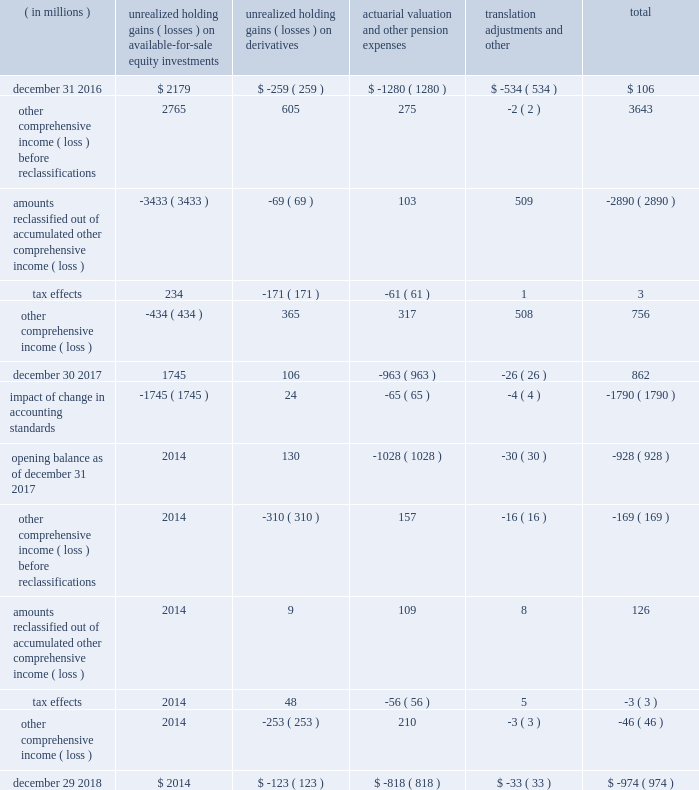Assets measured and recorded at fair value on a non-recurring basis our non-marketable equity securities , equity method investments , and certain non-financial assets , such as intangible assets and property , plant and equipment , are recorded at fair value only if an impairment or observable price adjustment is recognized in the current period .
If an impairment or observable price adjustment is recognized on our non-marketable equity securities during the period , we classify these assets as level 3 within the fair value hierarchy based on the nature of the fair value inputs .
We classified non-marketable equity securities and non-marketable equity method investments as level 3 .
Impairments recognized on these investments held as of december 29 , 2018 were $ 416 million ( $ 537 million held as of december 30 , 2017 and $ 153 million held as of december 31 , 2016 ) .
Financial instruments not recorded at fair value on a recurring basis financial instruments not recorded at fair value on a recurring basis include non-marketable equity securities and equity method investments that have not been remeasured or impaired in the current period , grants receivable , loans receivable , reverse repurchase agreements , and our short-term and long-term debt .
Prior to the adoption of the new financial instrument standard , our non-marketable cost method investments were disclosed at fair value on a recurring basis .
The carrying amount and fair value of our non-marketable cost method investments as of december 30 , 2017 were $ 2.6 billion and $ 3.6 billion , respectively .
These measures are classified as level 3 within the fair value hierarchy based on the nature of the fair value inputs .
As of december 29 , 2018 , the aggregate carrying value of grants receivable , loans receivable , and reverse repurchase agreements was $ 833 million ( the aggregate carrying amount as of december 30 , 2017 was $ 935 million ) .
The estimated fair value of these financial instruments approximates their carrying value and is categorized as level 2 within the fair value hierarchy based on the nature of the fair value inputs .
For information related to the fair value of our short-term and long-term debt , see 201cnote 15 : borrowings . 201d note 17 : other comprehensive income ( loss ) the changes in accumulated other comprehensive income ( loss ) by component and related tax effects for each period were as follows : ( in millions ) unrealized holding ( losses ) on available-for -sale equity investments unrealized holding ( losses ) on derivatives actuarial valuation and other pension expenses translation adjustments and other total .
Financial statements notes to financial statements 97 .
What is the net change in the accumulated other comprehensive income during 2017? 
Computations: (862 - 106)
Answer: 756.0. Assets measured and recorded at fair value on a non-recurring basis our non-marketable equity securities , equity method investments , and certain non-financial assets , such as intangible assets and property , plant and equipment , are recorded at fair value only if an impairment or observable price adjustment is recognized in the current period .
If an impairment or observable price adjustment is recognized on our non-marketable equity securities during the period , we classify these assets as level 3 within the fair value hierarchy based on the nature of the fair value inputs .
We classified non-marketable equity securities and non-marketable equity method investments as level 3 .
Impairments recognized on these investments held as of december 29 , 2018 were $ 416 million ( $ 537 million held as of december 30 , 2017 and $ 153 million held as of december 31 , 2016 ) .
Financial instruments not recorded at fair value on a recurring basis financial instruments not recorded at fair value on a recurring basis include non-marketable equity securities and equity method investments that have not been remeasured or impaired in the current period , grants receivable , loans receivable , reverse repurchase agreements , and our short-term and long-term debt .
Prior to the adoption of the new financial instrument standard , our non-marketable cost method investments were disclosed at fair value on a recurring basis .
The carrying amount and fair value of our non-marketable cost method investments as of december 30 , 2017 were $ 2.6 billion and $ 3.6 billion , respectively .
These measures are classified as level 3 within the fair value hierarchy based on the nature of the fair value inputs .
As of december 29 , 2018 , the aggregate carrying value of grants receivable , loans receivable , and reverse repurchase agreements was $ 833 million ( the aggregate carrying amount as of december 30 , 2017 was $ 935 million ) .
The estimated fair value of these financial instruments approximates their carrying value and is categorized as level 2 within the fair value hierarchy based on the nature of the fair value inputs .
For information related to the fair value of our short-term and long-term debt , see 201cnote 15 : borrowings . 201d note 17 : other comprehensive income ( loss ) the changes in accumulated other comprehensive income ( loss ) by component and related tax effects for each period were as follows : ( in millions ) unrealized holding ( losses ) on available-for -sale equity investments unrealized holding ( losses ) on derivatives actuarial valuation and other pension expenses translation adjustments and other total .
Financial statements notes to financial statements 97 .
What is the net change in the accumulated other comprehensive income during 2018? 
Computations: (-974 - 862)
Answer: -1836.0. 